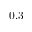Convert formula to latex. <formula><loc_0><loc_0><loc_500><loc_500>0 . 3</formula> 